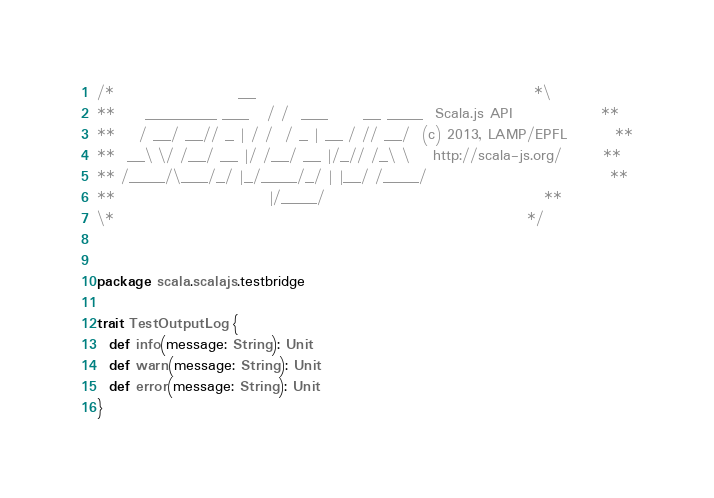Convert code to text. <code><loc_0><loc_0><loc_500><loc_500><_Scala_>/*                     __                                               *\
**     ________ ___   / /  ___      __ ____  Scala.js API               **
**    / __/ __// _ | / /  / _ | __ / // __/  (c) 2013, LAMP/EPFL        **
**  __\ \/ /__/ __ |/ /__/ __ |/_// /_\ \    http://scala-js.org/       **
** /____/\___/_/ |_/____/_/ | |__/ /____/                               **
**                          |/____/                                     **
\*                                                                      */


package scala.scalajs.testbridge

trait TestOutputLog {
  def info(message: String): Unit
  def warn(message: String): Unit
  def error(message: String): Unit
}
</code> 